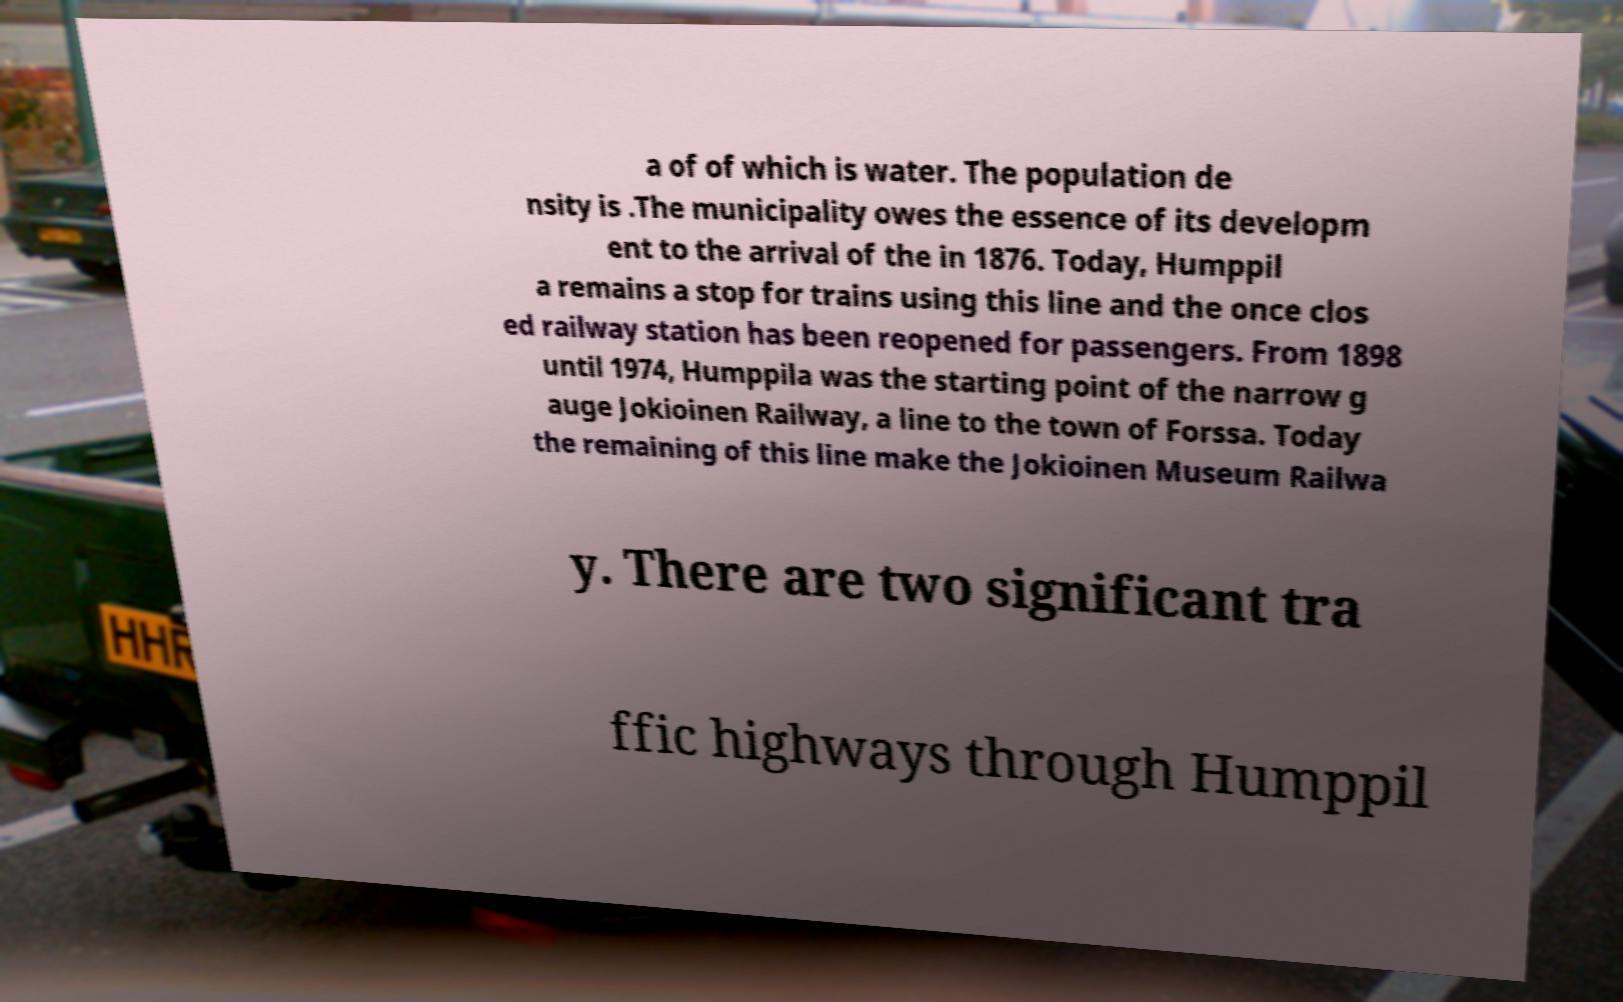Could you extract and type out the text from this image? a of of which is water. The population de nsity is .The municipality owes the essence of its developm ent to the arrival of the in 1876. Today, Humppil a remains a stop for trains using this line and the once clos ed railway station has been reopened for passengers. From 1898 until 1974, Humppila was the starting point of the narrow g auge Jokioinen Railway, a line to the town of Forssa. Today the remaining of this line make the Jokioinen Museum Railwa y. There are two significant tra ffic highways through Humppil 